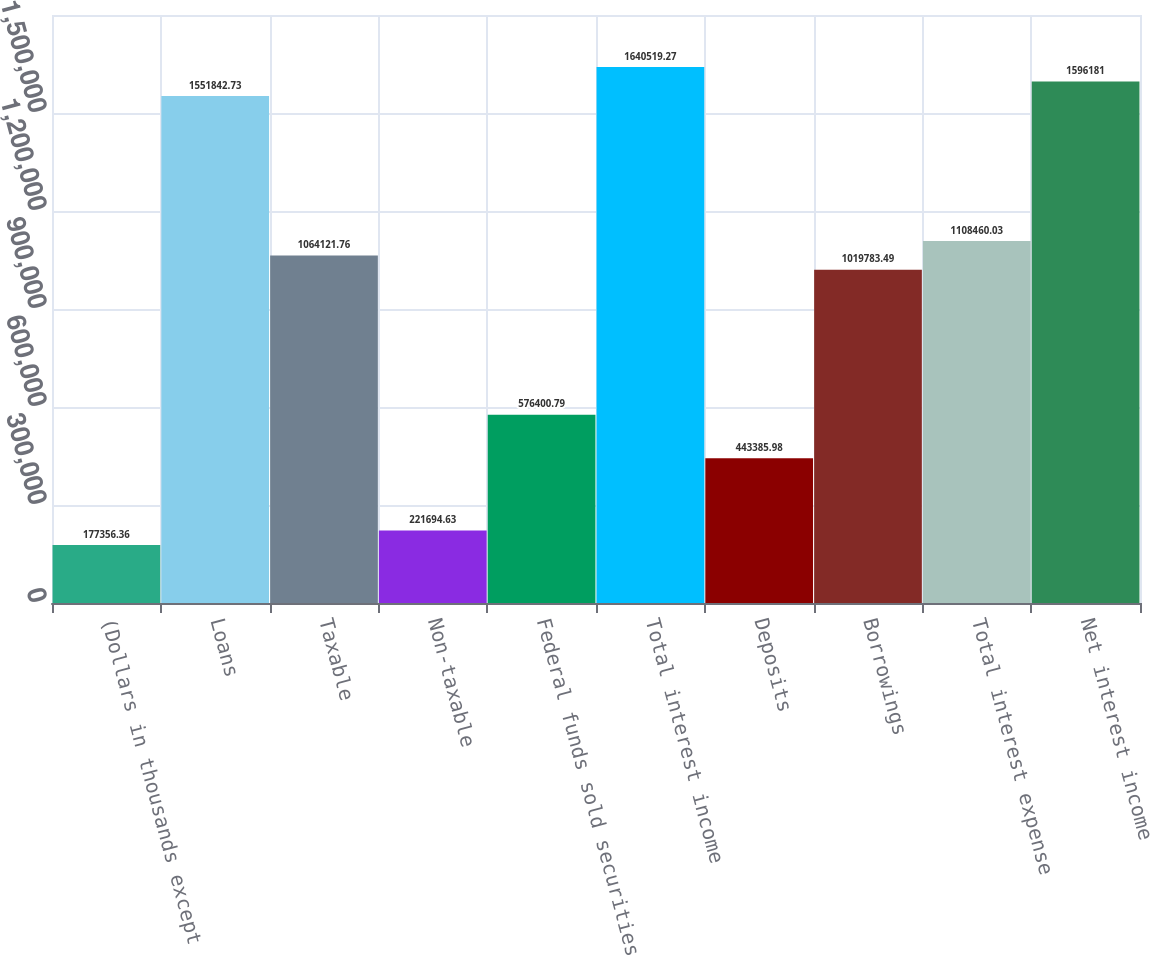Convert chart to OTSL. <chart><loc_0><loc_0><loc_500><loc_500><bar_chart><fcel>(Dollars in thousands except<fcel>Loans<fcel>Taxable<fcel>Non-taxable<fcel>Federal funds sold securities<fcel>Total interest income<fcel>Deposits<fcel>Borrowings<fcel>Total interest expense<fcel>Net interest income<nl><fcel>177356<fcel>1.55184e+06<fcel>1.06412e+06<fcel>221695<fcel>576401<fcel>1.64052e+06<fcel>443386<fcel>1.01978e+06<fcel>1.10846e+06<fcel>1.59618e+06<nl></chart> 